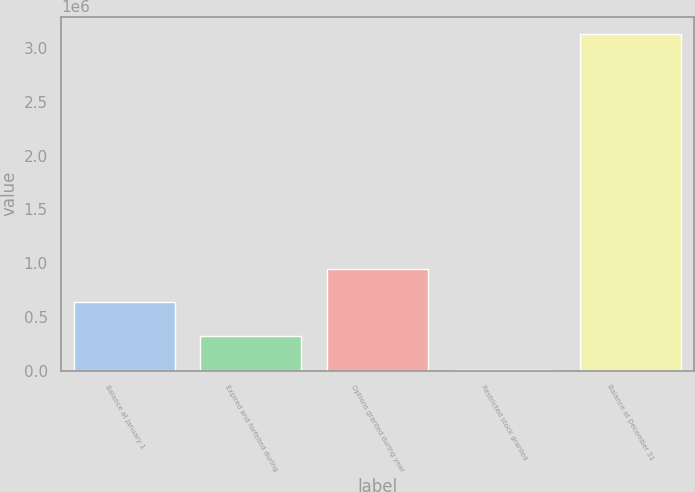<chart> <loc_0><loc_0><loc_500><loc_500><bar_chart><fcel>Balance at January 1<fcel>Expired and forfeited during<fcel>Options granted during year<fcel>Restricted stock granted<fcel>Balance at December 31<nl><fcel>635200<fcel>322600<fcel>947800<fcel>10000<fcel>3.136e+06<nl></chart> 